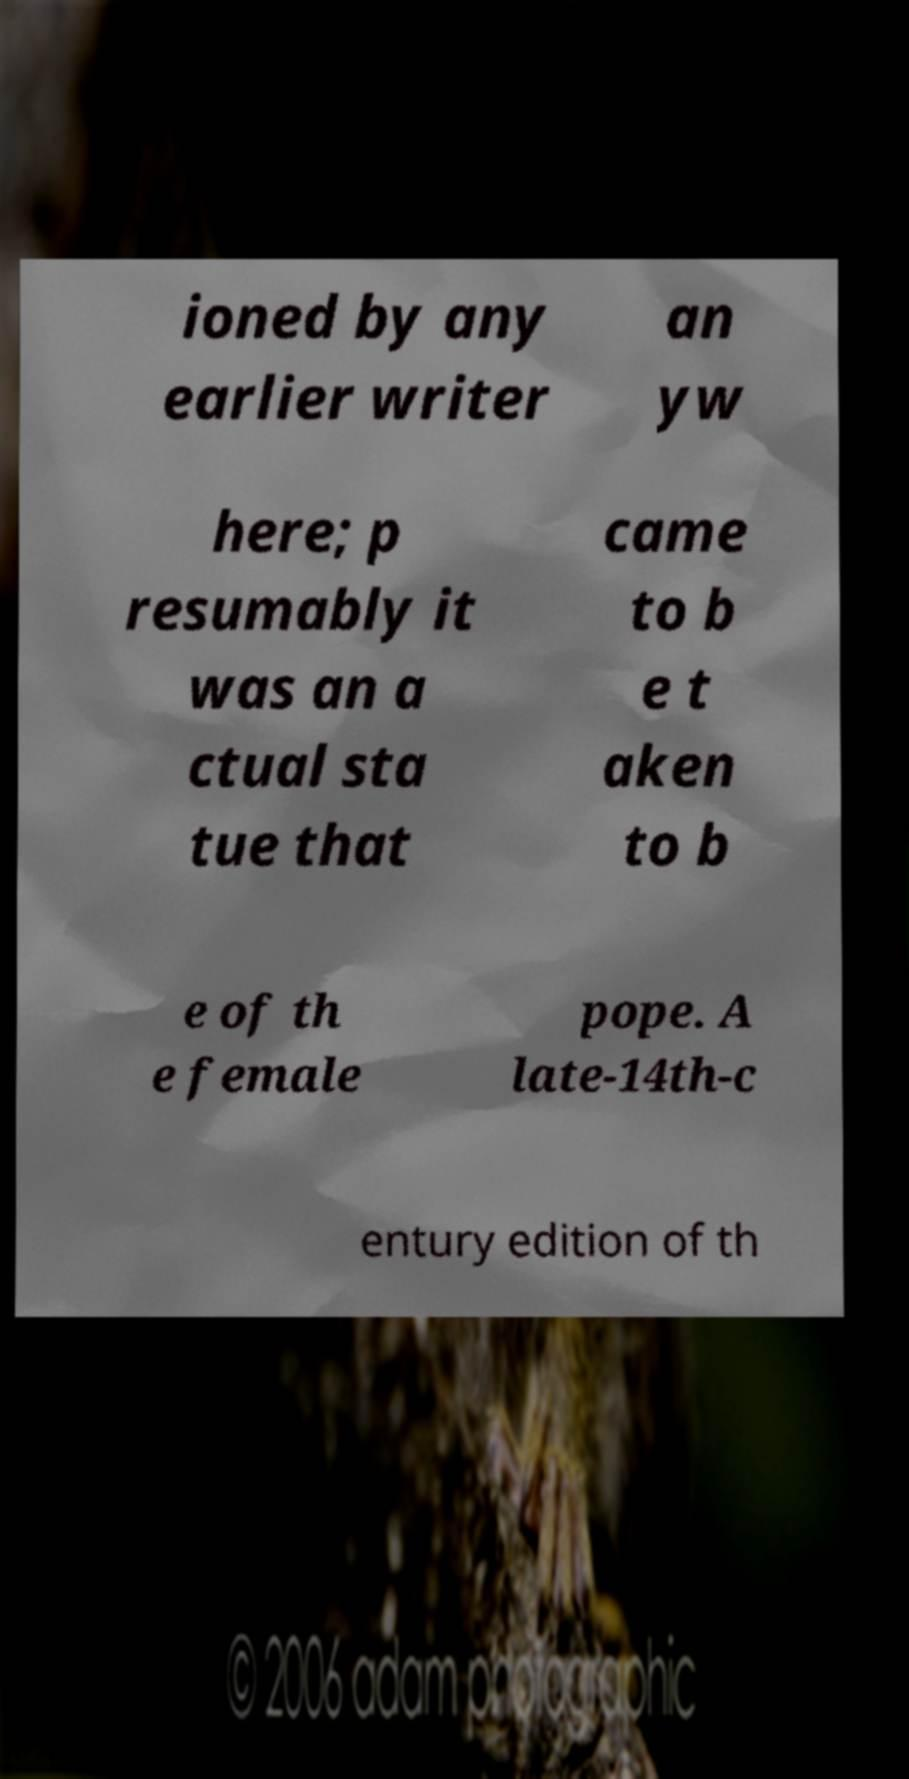Could you assist in decoding the text presented in this image and type it out clearly? ioned by any earlier writer an yw here; p resumably it was an a ctual sta tue that came to b e t aken to b e of th e female pope. A late-14th-c entury edition of th 